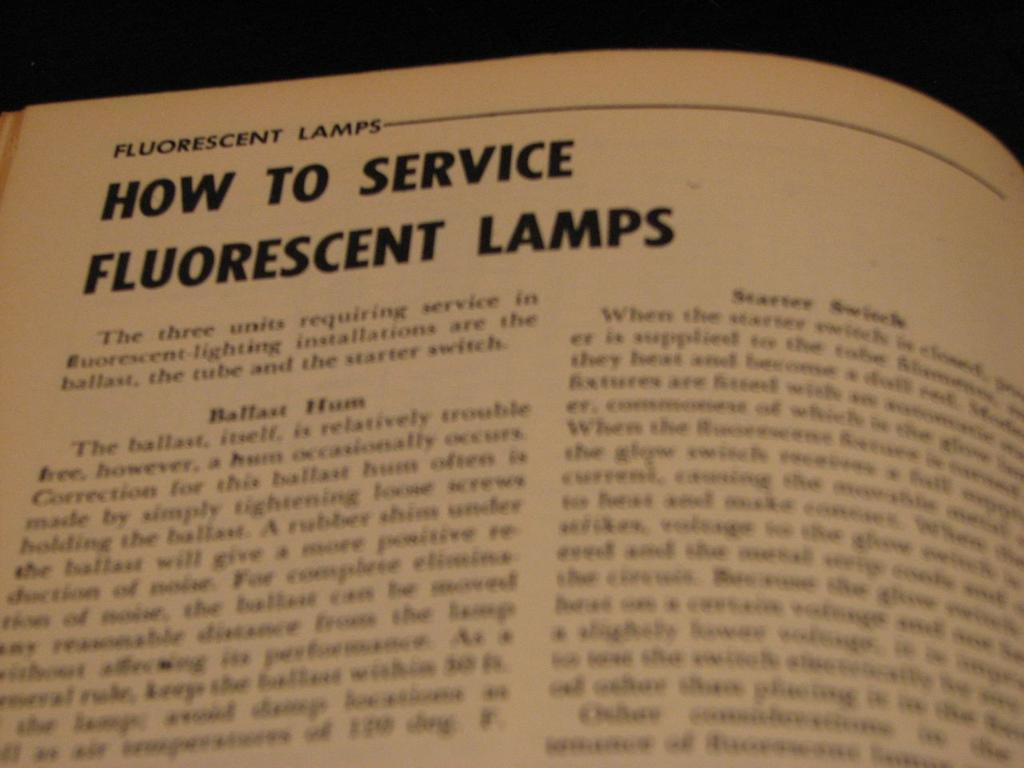<image>
Relay a brief, clear account of the picture shown. An article about how to service fluorescent lamps begins with the words "The three units". 